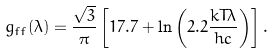Convert formula to latex. <formula><loc_0><loc_0><loc_500><loc_500>g _ { f f } ( \lambda ) = \frac { \sqrt { 3 } } { \pi } \left [ 1 7 . 7 + \ln \left ( 2 . 2 \frac { k T \lambda } { h c } \right ) \right ] .</formula> 